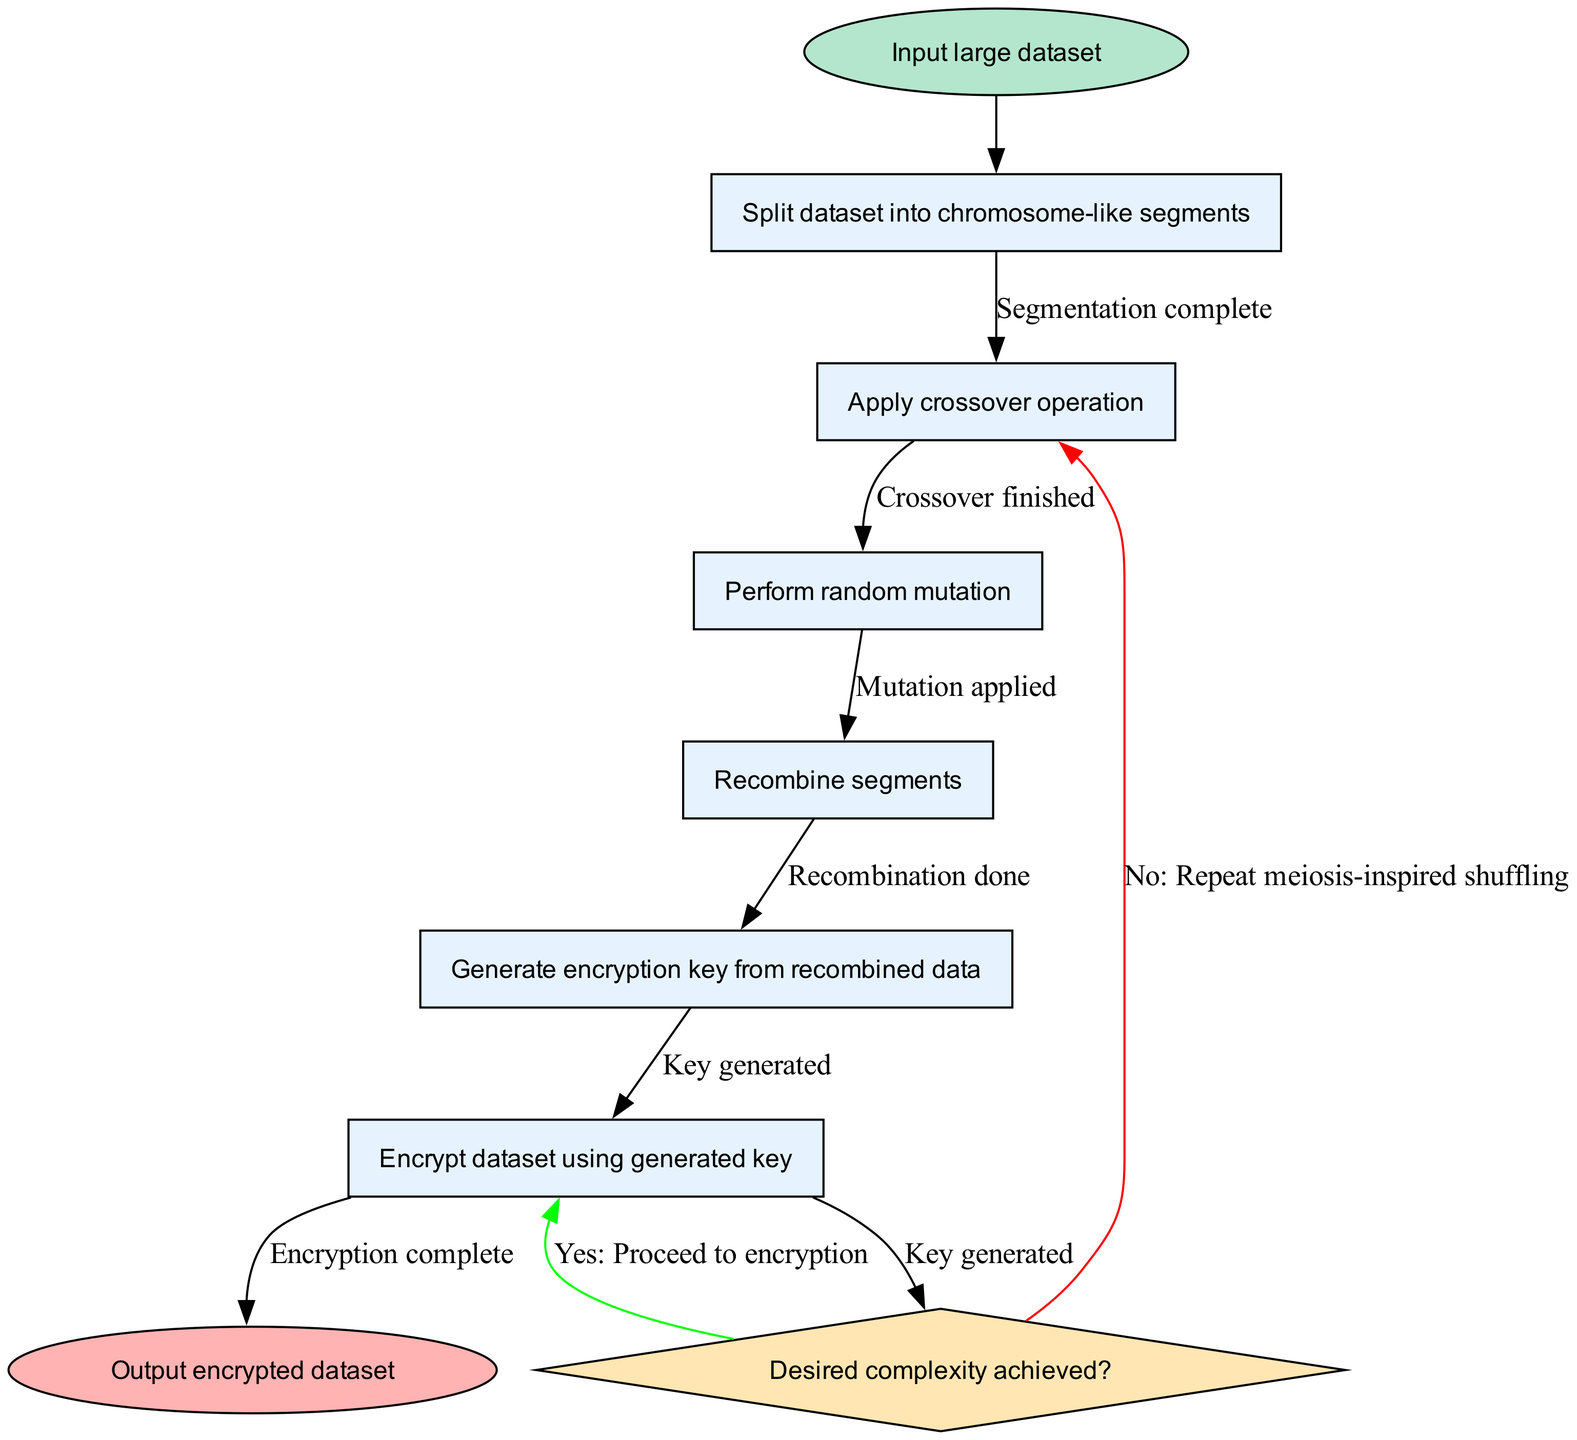What is the start node of the diagram? The start node is labeled "Input large dataset", which is the first step in the process.
Answer: Input large dataset How many activities are listed in the diagram? There are a total of six activities listed in the diagram, specifically enumerated in the activities section.
Answer: Six Which activity follows the "Apply crossover operation"? The activity that follows is "Perform random mutation", based on the sequential flow of the activities.
Answer: Perform random mutation What happens if the desired complexity is not achieved? If the desired complexity is not achieved, the process will "Repeat meiosis-inspired shuffling", as indicated in the decision node.
Answer: Repeat meiosis-inspired shuffling What is the final output of the diagram? The final output stated in the end node is "Output encrypted dataset", marking the completion of the algorithm.
Answer: Output encrypted dataset How many edges are connecting the activities in the diagram? There are five edges connecting the activities, reflecting the transitions between each step in the process.
Answer: Five What is the last activity before reaching the decision node? The last activity before the decision node is "Recombine segments", which is the final activity to occur before evaluation.
Answer: Recombine segments If the answer to "Desired complexity achieved?" is yes, what is the next step? If the answer is yes, the next step is to "Proceed to encryption", as indicated by the decision node's green edge.
Answer: Proceed to encryption Which activity generates the encryption key? The activity responsible for generating the encryption key is "Generate encryption key from recombined data", as identified in the activities list.
Answer: Generate encryption key from recombined data 